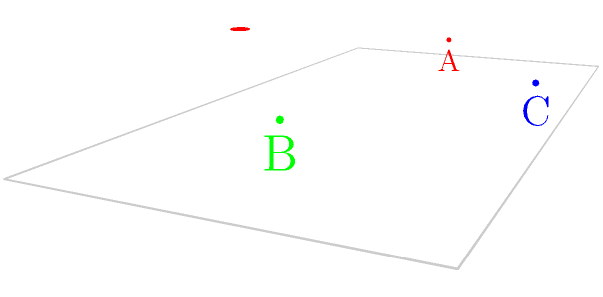As a devoted fan of KK Mladost Čačak, you're familiar with different views of the basketball hoop from various positions in the stadium. From which vantage point (A, B, or C) would the basketball hoop appear as a perfect circle? To determine from which vantage point the basketball hoop would appear as a perfect circle, we need to consider the principles of perspective and spatial geometry:

1. The basketball hoop is a circle in 3D space, parallel to the court's surface.

2. A circle appears as a perfect circle when viewed along its normal axis (perpendicular to its plane).

3. Let's analyze each vantage point:

   A (red): Located at one side of the court. From this angle, the hoop would appear as an ellipse due to perspective distortion.
   
   B (green): Located on the opposite side of the court from A. Similar to A, the hoop would appear as an ellipse, but mirrored.
   
   C (blue): Located at the center of the baseline, directly in front of the hoop.

4. The hoop's normal axis is perpendicular to the backboard and parallel to the court's length.

5. Point C is positioned along this normal axis, looking straight at the hoop.

Therefore, from vantage point C, the basketball hoop would appear as a perfect circle, as it's being viewed along its normal axis without any perspective distortion.
Answer: C 